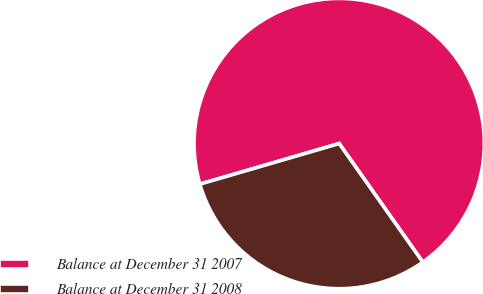Convert chart to OTSL. <chart><loc_0><loc_0><loc_500><loc_500><pie_chart><fcel>Balance at December 31 2007<fcel>Balance at December 31 2008<nl><fcel>69.74%<fcel>30.26%<nl></chart> 